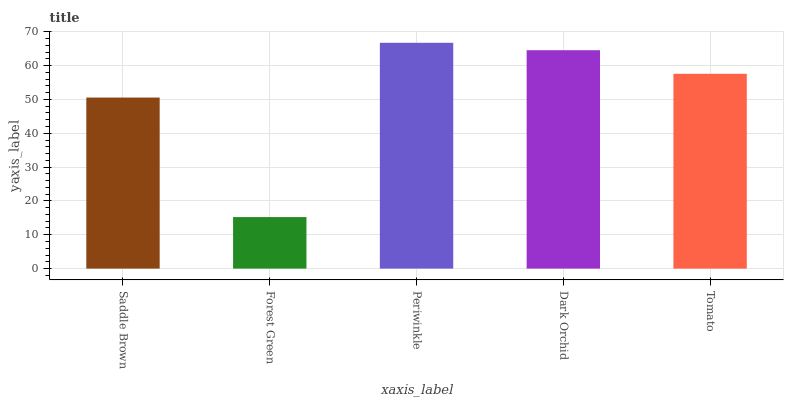Is Forest Green the minimum?
Answer yes or no. Yes. Is Periwinkle the maximum?
Answer yes or no. Yes. Is Periwinkle the minimum?
Answer yes or no. No. Is Forest Green the maximum?
Answer yes or no. No. Is Periwinkle greater than Forest Green?
Answer yes or no. Yes. Is Forest Green less than Periwinkle?
Answer yes or no. Yes. Is Forest Green greater than Periwinkle?
Answer yes or no. No. Is Periwinkle less than Forest Green?
Answer yes or no. No. Is Tomato the high median?
Answer yes or no. Yes. Is Tomato the low median?
Answer yes or no. Yes. Is Periwinkle the high median?
Answer yes or no. No. Is Forest Green the low median?
Answer yes or no. No. 